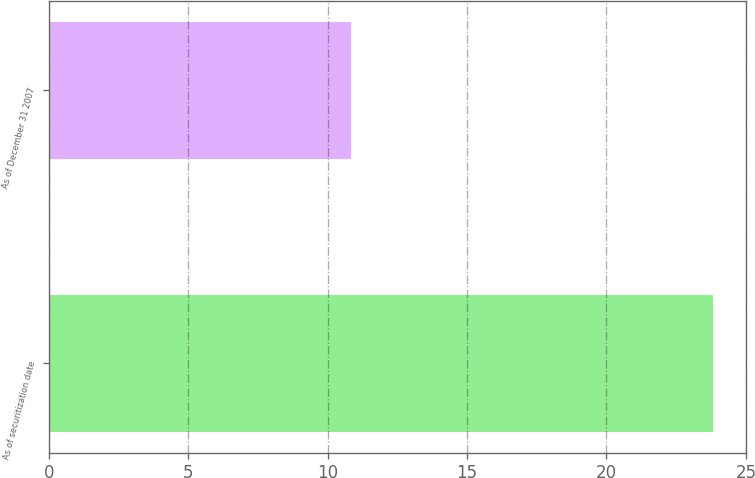Convert chart to OTSL. <chart><loc_0><loc_0><loc_500><loc_500><bar_chart><fcel>As of securitization date<fcel>As of December 31 2007<nl><fcel>23.81<fcel>10.82<nl></chart> 